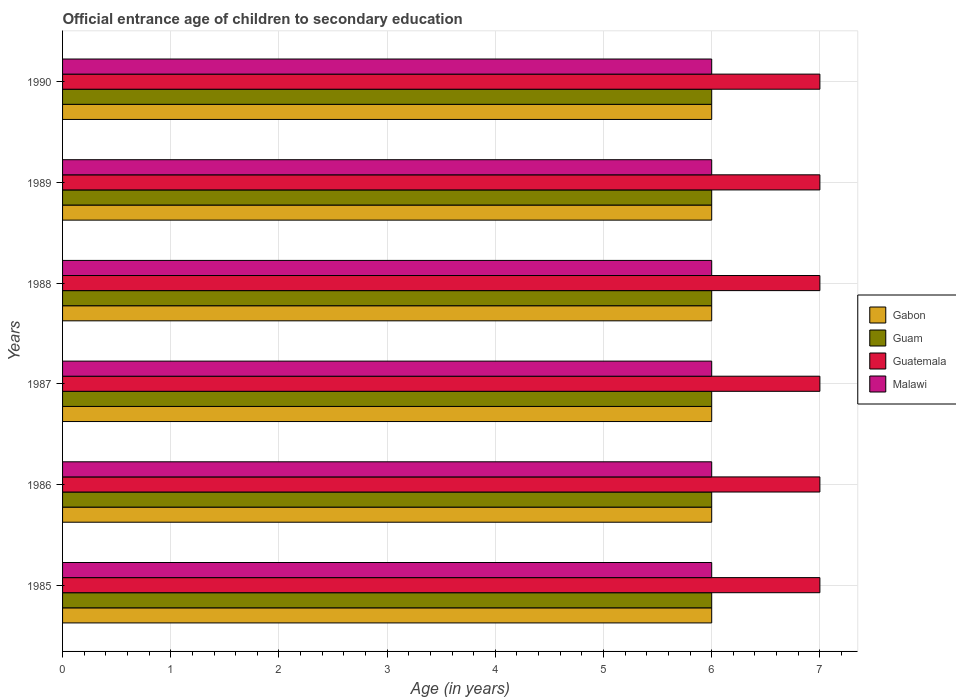How many groups of bars are there?
Your answer should be very brief. 6. Are the number of bars on each tick of the Y-axis equal?
Make the answer very short. Yes. How many bars are there on the 6th tick from the top?
Offer a terse response. 4. How many bars are there on the 6th tick from the bottom?
Ensure brevity in your answer.  4. What is the label of the 3rd group of bars from the top?
Provide a succinct answer. 1988. In how many cases, is the number of bars for a given year not equal to the number of legend labels?
Provide a short and direct response. 0. What is the secondary school starting age of children in Guatemala in 1986?
Offer a terse response. 7. Across all years, what is the minimum secondary school starting age of children in Guatemala?
Keep it short and to the point. 7. In which year was the secondary school starting age of children in Malawi maximum?
Ensure brevity in your answer.  1985. In which year was the secondary school starting age of children in Gabon minimum?
Your response must be concise. 1985. What is the total secondary school starting age of children in Gabon in the graph?
Provide a succinct answer. 36. What is the difference between the secondary school starting age of children in Guatemala in 1990 and the secondary school starting age of children in Malawi in 1985?
Offer a terse response. 1. What is the average secondary school starting age of children in Guam per year?
Your response must be concise. 6. Is the difference between the secondary school starting age of children in Malawi in 1986 and 1990 greater than the difference between the secondary school starting age of children in Gabon in 1986 and 1990?
Your answer should be very brief. No. What is the difference between the highest and the lowest secondary school starting age of children in Gabon?
Give a very brief answer. 0. Is it the case that in every year, the sum of the secondary school starting age of children in Guatemala and secondary school starting age of children in Malawi is greater than the sum of secondary school starting age of children in Guam and secondary school starting age of children in Gabon?
Your answer should be compact. Yes. What does the 1st bar from the top in 1989 represents?
Give a very brief answer. Malawi. What does the 4th bar from the bottom in 1985 represents?
Your answer should be very brief. Malawi. Is it the case that in every year, the sum of the secondary school starting age of children in Malawi and secondary school starting age of children in Gabon is greater than the secondary school starting age of children in Guatemala?
Your answer should be very brief. Yes. How many bars are there?
Ensure brevity in your answer.  24. What is the title of the graph?
Ensure brevity in your answer.  Official entrance age of children to secondary education. Does "Czech Republic" appear as one of the legend labels in the graph?
Keep it short and to the point. No. What is the label or title of the X-axis?
Give a very brief answer. Age (in years). What is the Age (in years) in Gabon in 1985?
Your answer should be compact. 6. What is the Age (in years) in Gabon in 1986?
Offer a very short reply. 6. What is the Age (in years) of Guam in 1986?
Ensure brevity in your answer.  6. What is the Age (in years) of Guam in 1987?
Make the answer very short. 6. What is the Age (in years) in Guatemala in 1987?
Keep it short and to the point. 7. What is the Age (in years) in Malawi in 1988?
Make the answer very short. 6. What is the Age (in years) of Guam in 1989?
Make the answer very short. 6. What is the Age (in years) of Guatemala in 1989?
Your answer should be compact. 7. What is the Age (in years) of Malawi in 1989?
Give a very brief answer. 6. What is the Age (in years) in Gabon in 1990?
Offer a very short reply. 6. What is the Age (in years) in Guatemala in 1990?
Make the answer very short. 7. Across all years, what is the maximum Age (in years) of Guatemala?
Keep it short and to the point. 7. Across all years, what is the minimum Age (in years) of Gabon?
Provide a short and direct response. 6. Across all years, what is the minimum Age (in years) of Malawi?
Your answer should be compact. 6. What is the total Age (in years) in Guam in the graph?
Provide a short and direct response. 36. What is the difference between the Age (in years) in Malawi in 1985 and that in 1986?
Provide a succinct answer. 0. What is the difference between the Age (in years) of Gabon in 1985 and that in 1987?
Offer a terse response. 0. What is the difference between the Age (in years) of Guam in 1985 and that in 1987?
Offer a very short reply. 0. What is the difference between the Age (in years) in Guatemala in 1985 and that in 1987?
Offer a terse response. 0. What is the difference between the Age (in years) of Malawi in 1985 and that in 1987?
Provide a succinct answer. 0. What is the difference between the Age (in years) in Gabon in 1985 and that in 1988?
Ensure brevity in your answer.  0. What is the difference between the Age (in years) in Guam in 1985 and that in 1988?
Your response must be concise. 0. What is the difference between the Age (in years) in Gabon in 1985 and that in 1989?
Your answer should be very brief. 0. What is the difference between the Age (in years) in Guam in 1985 and that in 1989?
Your answer should be very brief. 0. What is the difference between the Age (in years) of Guam in 1985 and that in 1990?
Your answer should be very brief. 0. What is the difference between the Age (in years) of Malawi in 1985 and that in 1990?
Ensure brevity in your answer.  0. What is the difference between the Age (in years) in Gabon in 1986 and that in 1987?
Your response must be concise. 0. What is the difference between the Age (in years) of Guatemala in 1986 and that in 1987?
Provide a succinct answer. 0. What is the difference between the Age (in years) of Malawi in 1986 and that in 1987?
Keep it short and to the point. 0. What is the difference between the Age (in years) in Gabon in 1986 and that in 1988?
Your answer should be very brief. 0. What is the difference between the Age (in years) in Guam in 1986 and that in 1988?
Give a very brief answer. 0. What is the difference between the Age (in years) in Guatemala in 1986 and that in 1988?
Your response must be concise. 0. What is the difference between the Age (in years) of Malawi in 1986 and that in 1988?
Your answer should be very brief. 0. What is the difference between the Age (in years) in Guam in 1986 and that in 1989?
Your answer should be very brief. 0. What is the difference between the Age (in years) in Guatemala in 1986 and that in 1989?
Offer a terse response. 0. What is the difference between the Age (in years) of Guam in 1986 and that in 1990?
Provide a succinct answer. 0. What is the difference between the Age (in years) of Malawi in 1986 and that in 1990?
Ensure brevity in your answer.  0. What is the difference between the Age (in years) of Guam in 1987 and that in 1988?
Provide a short and direct response. 0. What is the difference between the Age (in years) in Guatemala in 1987 and that in 1988?
Give a very brief answer. 0. What is the difference between the Age (in years) in Guatemala in 1987 and that in 1989?
Ensure brevity in your answer.  0. What is the difference between the Age (in years) in Guatemala in 1987 and that in 1990?
Give a very brief answer. 0. What is the difference between the Age (in years) of Malawi in 1987 and that in 1990?
Ensure brevity in your answer.  0. What is the difference between the Age (in years) in Gabon in 1988 and that in 1989?
Provide a succinct answer. 0. What is the difference between the Age (in years) of Guatemala in 1988 and that in 1989?
Keep it short and to the point. 0. What is the difference between the Age (in years) of Guatemala in 1988 and that in 1990?
Provide a short and direct response. 0. What is the difference between the Age (in years) of Guam in 1989 and that in 1990?
Give a very brief answer. 0. What is the difference between the Age (in years) of Guatemala in 1989 and that in 1990?
Offer a terse response. 0. What is the difference between the Age (in years) in Malawi in 1989 and that in 1990?
Your answer should be compact. 0. What is the difference between the Age (in years) of Gabon in 1985 and the Age (in years) of Guam in 1986?
Provide a short and direct response. 0. What is the difference between the Age (in years) of Gabon in 1985 and the Age (in years) of Guatemala in 1986?
Your answer should be very brief. -1. What is the difference between the Age (in years) of Gabon in 1985 and the Age (in years) of Malawi in 1986?
Offer a very short reply. 0. What is the difference between the Age (in years) of Guam in 1985 and the Age (in years) of Malawi in 1986?
Your answer should be compact. 0. What is the difference between the Age (in years) of Guatemala in 1985 and the Age (in years) of Malawi in 1986?
Your answer should be compact. 1. What is the difference between the Age (in years) in Gabon in 1985 and the Age (in years) in Guam in 1987?
Make the answer very short. 0. What is the difference between the Age (in years) in Guam in 1985 and the Age (in years) in Guatemala in 1987?
Offer a terse response. -1. What is the difference between the Age (in years) in Gabon in 1985 and the Age (in years) in Guam in 1988?
Your answer should be compact. 0. What is the difference between the Age (in years) in Gabon in 1985 and the Age (in years) in Guatemala in 1988?
Provide a short and direct response. -1. What is the difference between the Age (in years) of Gabon in 1985 and the Age (in years) of Malawi in 1988?
Provide a short and direct response. 0. What is the difference between the Age (in years) of Gabon in 1985 and the Age (in years) of Guam in 1989?
Make the answer very short. 0. What is the difference between the Age (in years) in Gabon in 1985 and the Age (in years) in Guatemala in 1989?
Ensure brevity in your answer.  -1. What is the difference between the Age (in years) in Guam in 1985 and the Age (in years) in Guatemala in 1990?
Offer a terse response. -1. What is the difference between the Age (in years) of Guatemala in 1985 and the Age (in years) of Malawi in 1990?
Provide a short and direct response. 1. What is the difference between the Age (in years) in Gabon in 1986 and the Age (in years) in Guatemala in 1987?
Make the answer very short. -1. What is the difference between the Age (in years) in Guam in 1986 and the Age (in years) in Guatemala in 1987?
Make the answer very short. -1. What is the difference between the Age (in years) of Guam in 1986 and the Age (in years) of Malawi in 1987?
Your response must be concise. 0. What is the difference between the Age (in years) in Guatemala in 1986 and the Age (in years) in Malawi in 1987?
Ensure brevity in your answer.  1. What is the difference between the Age (in years) of Gabon in 1986 and the Age (in years) of Malawi in 1988?
Make the answer very short. 0. What is the difference between the Age (in years) of Guam in 1986 and the Age (in years) of Guatemala in 1988?
Your answer should be very brief. -1. What is the difference between the Age (in years) in Guatemala in 1986 and the Age (in years) in Malawi in 1988?
Make the answer very short. 1. What is the difference between the Age (in years) of Gabon in 1986 and the Age (in years) of Guam in 1989?
Ensure brevity in your answer.  0. What is the difference between the Age (in years) in Gabon in 1986 and the Age (in years) in Guatemala in 1989?
Your answer should be very brief. -1. What is the difference between the Age (in years) of Guam in 1986 and the Age (in years) of Guatemala in 1989?
Your response must be concise. -1. What is the difference between the Age (in years) of Guam in 1986 and the Age (in years) of Malawi in 1989?
Provide a short and direct response. 0. What is the difference between the Age (in years) in Guatemala in 1986 and the Age (in years) in Malawi in 1989?
Your answer should be compact. 1. What is the difference between the Age (in years) in Gabon in 1986 and the Age (in years) in Guam in 1990?
Keep it short and to the point. 0. What is the difference between the Age (in years) in Gabon in 1986 and the Age (in years) in Malawi in 1990?
Your response must be concise. 0. What is the difference between the Age (in years) of Guam in 1986 and the Age (in years) of Guatemala in 1990?
Give a very brief answer. -1. What is the difference between the Age (in years) of Guatemala in 1986 and the Age (in years) of Malawi in 1990?
Make the answer very short. 1. What is the difference between the Age (in years) in Gabon in 1987 and the Age (in years) in Malawi in 1988?
Give a very brief answer. 0. What is the difference between the Age (in years) of Gabon in 1987 and the Age (in years) of Guatemala in 1989?
Keep it short and to the point. -1. What is the difference between the Age (in years) in Guam in 1987 and the Age (in years) in Malawi in 1989?
Make the answer very short. 0. What is the difference between the Age (in years) of Gabon in 1987 and the Age (in years) of Malawi in 1990?
Your answer should be compact. 0. What is the difference between the Age (in years) of Guatemala in 1987 and the Age (in years) of Malawi in 1990?
Offer a very short reply. 1. What is the difference between the Age (in years) of Gabon in 1988 and the Age (in years) of Guam in 1989?
Provide a short and direct response. 0. What is the difference between the Age (in years) in Gabon in 1988 and the Age (in years) in Guatemala in 1989?
Make the answer very short. -1. What is the difference between the Age (in years) of Guam in 1988 and the Age (in years) of Malawi in 1989?
Your answer should be very brief. 0. What is the difference between the Age (in years) of Guatemala in 1988 and the Age (in years) of Malawi in 1989?
Your answer should be compact. 1. What is the difference between the Age (in years) in Gabon in 1988 and the Age (in years) in Guam in 1990?
Offer a terse response. 0. What is the difference between the Age (in years) of Gabon in 1988 and the Age (in years) of Guatemala in 1990?
Give a very brief answer. -1. What is the difference between the Age (in years) of Gabon in 1988 and the Age (in years) of Malawi in 1990?
Make the answer very short. 0. What is the difference between the Age (in years) of Guam in 1988 and the Age (in years) of Guatemala in 1990?
Your answer should be very brief. -1. What is the difference between the Age (in years) in Guam in 1988 and the Age (in years) in Malawi in 1990?
Make the answer very short. 0. What is the difference between the Age (in years) in Gabon in 1989 and the Age (in years) in Guatemala in 1990?
Your response must be concise. -1. What is the difference between the Age (in years) in Guam in 1989 and the Age (in years) in Malawi in 1990?
Make the answer very short. 0. What is the average Age (in years) in Gabon per year?
Offer a very short reply. 6. What is the average Age (in years) of Guam per year?
Your answer should be very brief. 6. What is the average Age (in years) of Guatemala per year?
Give a very brief answer. 7. In the year 1985, what is the difference between the Age (in years) in Gabon and Age (in years) in Guam?
Ensure brevity in your answer.  0. In the year 1985, what is the difference between the Age (in years) in Gabon and Age (in years) in Malawi?
Provide a succinct answer. 0. In the year 1985, what is the difference between the Age (in years) of Guam and Age (in years) of Guatemala?
Offer a very short reply. -1. In the year 1985, what is the difference between the Age (in years) of Guam and Age (in years) of Malawi?
Offer a very short reply. 0. In the year 1985, what is the difference between the Age (in years) of Guatemala and Age (in years) of Malawi?
Keep it short and to the point. 1. In the year 1986, what is the difference between the Age (in years) of Gabon and Age (in years) of Guam?
Your answer should be compact. 0. In the year 1986, what is the difference between the Age (in years) in Gabon and Age (in years) in Guatemala?
Give a very brief answer. -1. In the year 1986, what is the difference between the Age (in years) in Gabon and Age (in years) in Malawi?
Make the answer very short. 0. In the year 1986, what is the difference between the Age (in years) in Guam and Age (in years) in Guatemala?
Make the answer very short. -1. In the year 1987, what is the difference between the Age (in years) in Gabon and Age (in years) in Guam?
Provide a succinct answer. 0. In the year 1987, what is the difference between the Age (in years) of Guam and Age (in years) of Guatemala?
Provide a succinct answer. -1. In the year 1987, what is the difference between the Age (in years) of Guam and Age (in years) of Malawi?
Your response must be concise. 0. In the year 1988, what is the difference between the Age (in years) of Gabon and Age (in years) of Guatemala?
Keep it short and to the point. -1. In the year 1988, what is the difference between the Age (in years) of Gabon and Age (in years) of Malawi?
Provide a succinct answer. 0. In the year 1988, what is the difference between the Age (in years) of Guam and Age (in years) of Guatemala?
Give a very brief answer. -1. In the year 1988, what is the difference between the Age (in years) of Guam and Age (in years) of Malawi?
Offer a terse response. 0. In the year 1989, what is the difference between the Age (in years) in Gabon and Age (in years) in Guam?
Provide a succinct answer. 0. In the year 1989, what is the difference between the Age (in years) in Gabon and Age (in years) in Guatemala?
Offer a very short reply. -1. In the year 1990, what is the difference between the Age (in years) of Gabon and Age (in years) of Guam?
Your answer should be very brief. 0. In the year 1990, what is the difference between the Age (in years) of Gabon and Age (in years) of Malawi?
Offer a very short reply. 0. In the year 1990, what is the difference between the Age (in years) in Guam and Age (in years) in Guatemala?
Your answer should be very brief. -1. In the year 1990, what is the difference between the Age (in years) of Guatemala and Age (in years) of Malawi?
Give a very brief answer. 1. What is the ratio of the Age (in years) in Gabon in 1985 to that in 1986?
Make the answer very short. 1. What is the ratio of the Age (in years) in Guam in 1985 to that in 1986?
Your answer should be compact. 1. What is the ratio of the Age (in years) in Guatemala in 1985 to that in 1986?
Your response must be concise. 1. What is the ratio of the Age (in years) of Guam in 1985 to that in 1987?
Keep it short and to the point. 1. What is the ratio of the Age (in years) of Guatemala in 1985 to that in 1987?
Provide a short and direct response. 1. What is the ratio of the Age (in years) in Gabon in 1985 to that in 1988?
Keep it short and to the point. 1. What is the ratio of the Age (in years) in Guam in 1985 to that in 1988?
Offer a terse response. 1. What is the ratio of the Age (in years) of Guatemala in 1985 to that in 1988?
Your response must be concise. 1. What is the ratio of the Age (in years) of Malawi in 1985 to that in 1988?
Your response must be concise. 1. What is the ratio of the Age (in years) of Malawi in 1985 to that in 1989?
Your answer should be compact. 1. What is the ratio of the Age (in years) in Gabon in 1985 to that in 1990?
Make the answer very short. 1. What is the ratio of the Age (in years) of Guam in 1985 to that in 1990?
Offer a very short reply. 1. What is the ratio of the Age (in years) of Guam in 1986 to that in 1987?
Keep it short and to the point. 1. What is the ratio of the Age (in years) in Guatemala in 1986 to that in 1987?
Your response must be concise. 1. What is the ratio of the Age (in years) of Malawi in 1986 to that in 1987?
Give a very brief answer. 1. What is the ratio of the Age (in years) in Guam in 1986 to that in 1988?
Make the answer very short. 1. What is the ratio of the Age (in years) in Guatemala in 1986 to that in 1988?
Give a very brief answer. 1. What is the ratio of the Age (in years) in Malawi in 1986 to that in 1988?
Keep it short and to the point. 1. What is the ratio of the Age (in years) of Guam in 1986 to that in 1989?
Offer a terse response. 1. What is the ratio of the Age (in years) in Malawi in 1986 to that in 1990?
Provide a succinct answer. 1. What is the ratio of the Age (in years) in Gabon in 1987 to that in 1988?
Provide a short and direct response. 1. What is the ratio of the Age (in years) in Guatemala in 1987 to that in 1988?
Your response must be concise. 1. What is the ratio of the Age (in years) in Malawi in 1987 to that in 1988?
Offer a terse response. 1. What is the ratio of the Age (in years) in Guam in 1987 to that in 1989?
Keep it short and to the point. 1. What is the ratio of the Age (in years) in Guatemala in 1987 to that in 1989?
Make the answer very short. 1. What is the ratio of the Age (in years) in Malawi in 1987 to that in 1989?
Keep it short and to the point. 1. What is the ratio of the Age (in years) of Gabon in 1987 to that in 1990?
Your answer should be very brief. 1. What is the ratio of the Age (in years) of Guatemala in 1987 to that in 1990?
Your answer should be very brief. 1. What is the ratio of the Age (in years) of Guatemala in 1988 to that in 1989?
Give a very brief answer. 1. What is the ratio of the Age (in years) of Malawi in 1988 to that in 1989?
Your answer should be compact. 1. What is the ratio of the Age (in years) in Gabon in 1988 to that in 1990?
Your answer should be very brief. 1. What is the ratio of the Age (in years) of Guam in 1988 to that in 1990?
Make the answer very short. 1. What is the ratio of the Age (in years) in Guatemala in 1988 to that in 1990?
Your answer should be very brief. 1. What is the ratio of the Age (in years) of Malawi in 1988 to that in 1990?
Your answer should be compact. 1. What is the ratio of the Age (in years) of Guam in 1989 to that in 1990?
Ensure brevity in your answer.  1. What is the ratio of the Age (in years) of Malawi in 1989 to that in 1990?
Provide a short and direct response. 1. What is the difference between the highest and the second highest Age (in years) in Gabon?
Keep it short and to the point. 0. What is the difference between the highest and the second highest Age (in years) in Guatemala?
Your response must be concise. 0. What is the difference between the highest and the second highest Age (in years) in Malawi?
Provide a succinct answer. 0. What is the difference between the highest and the lowest Age (in years) in Guam?
Offer a terse response. 0. What is the difference between the highest and the lowest Age (in years) of Malawi?
Make the answer very short. 0. 